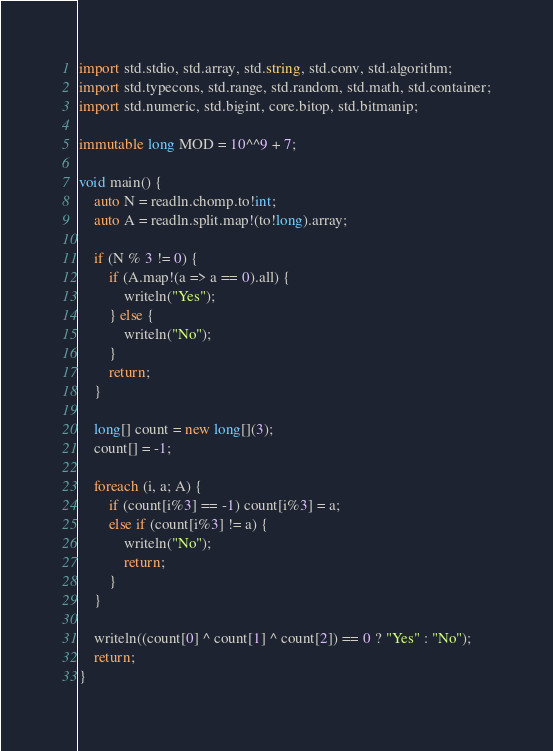Convert code to text. <code><loc_0><loc_0><loc_500><loc_500><_D_>import std.stdio, std.array, std.string, std.conv, std.algorithm;
import std.typecons, std.range, std.random, std.math, std.container;
import std.numeric, std.bigint, core.bitop, std.bitmanip;

immutable long MOD = 10^^9 + 7;

void main() {
    auto N = readln.chomp.to!int;
    auto A = readln.split.map!(to!long).array;

    if (N % 3 != 0) {
        if (A.map!(a => a == 0).all) {
            writeln("Yes");
        } else {
            writeln("No");
        }
        return;
    }

    long[] count = new long[](3);
    count[] = -1;

    foreach (i, a; A) {
        if (count[i%3] == -1) count[i%3] = a;
        else if (count[i%3] != a) {
            writeln("No");
            return;
        }
    }

    writeln((count[0] ^ count[1] ^ count[2]) == 0 ? "Yes" : "No");
    return;
}</code> 